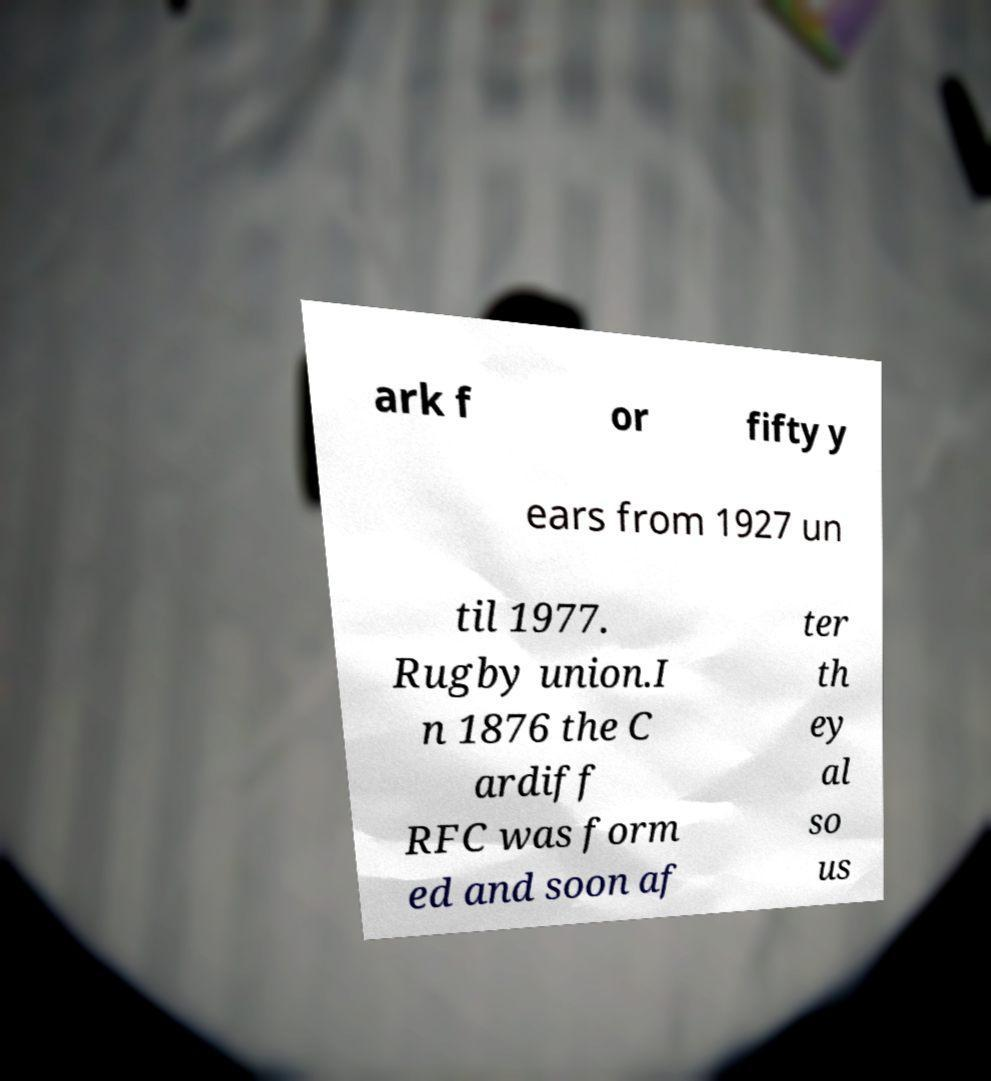Please identify and transcribe the text found in this image. ark f or fifty y ears from 1927 un til 1977. Rugby union.I n 1876 the C ardiff RFC was form ed and soon af ter th ey al so us 